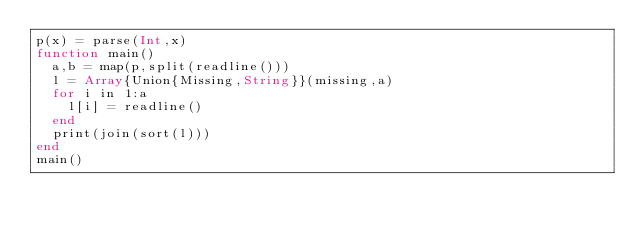<code> <loc_0><loc_0><loc_500><loc_500><_Julia_>p(x) = parse(Int,x)
function main()
  a,b = map(p,split(readline()))
  l = Array{Union{Missing,String}}(missing,a)
  for i in 1:a
    l[i] = readline()
  end
  print(join(sort(l)))
end
main()</code> 